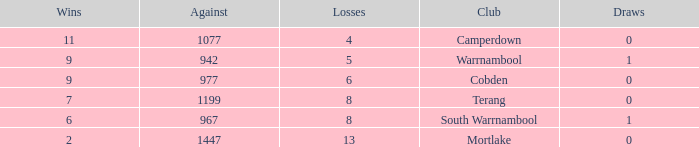How many draws did Mortlake have when the losses were more than 5? 1.0. 